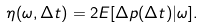<formula> <loc_0><loc_0><loc_500><loc_500>\eta ( \omega , \Delta t ) = 2 E [ \Delta p ( \Delta t ) | \omega ] .</formula> 